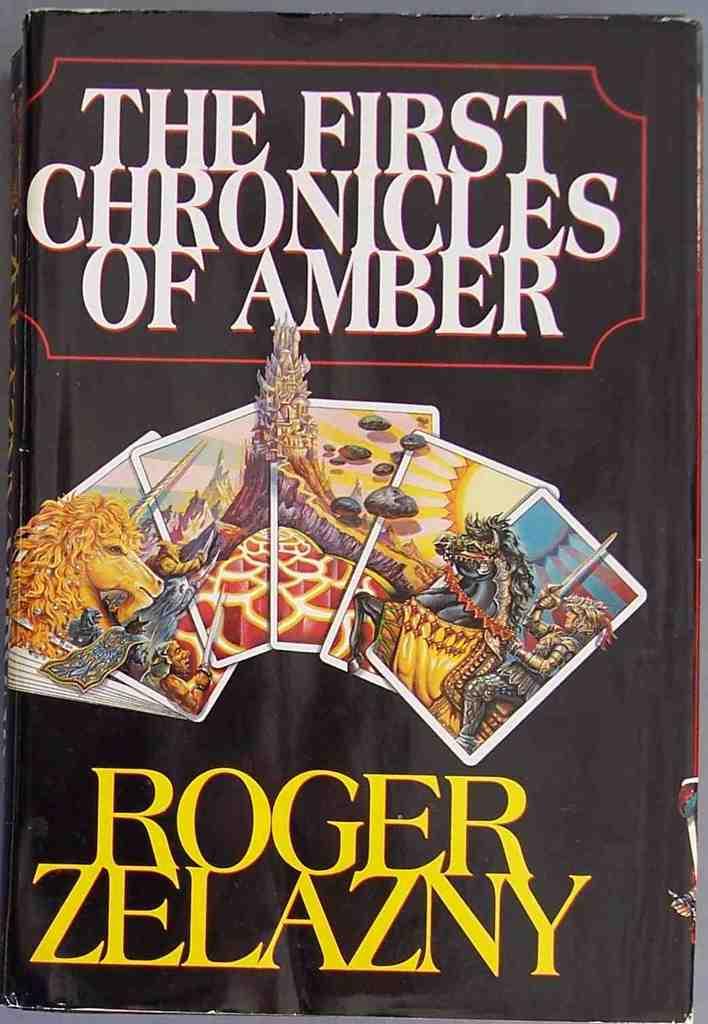Which book is this in the series?
Give a very brief answer. First. Who is the author of the book?
Ensure brevity in your answer.  Roger zelazny. 